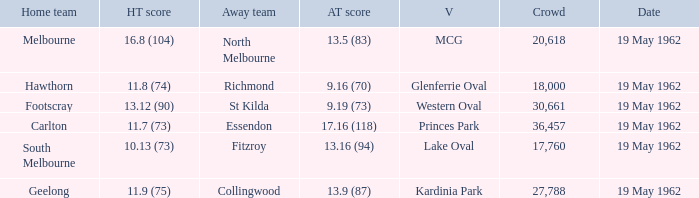What is the domestic team's score at mcg? 16.8 (104). 